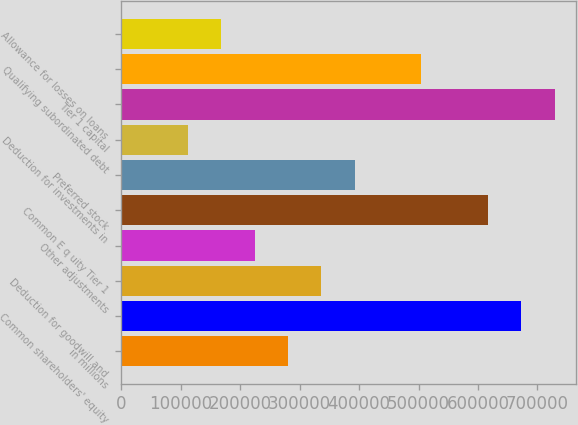<chart> <loc_0><loc_0><loc_500><loc_500><bar_chart><fcel>in millions<fcel>Common shareholders' equity<fcel>Deduction for goodwill and<fcel>Other adjustments<fcel>Common E q uity Tier 1<fcel>Preferred stock<fcel>Deduction for investments in<fcel>Tier 1 capital<fcel>Qualifying subordinated debt<fcel>Allowance for losses on loans<nl><fcel>280399<fcel>672941<fcel>336477<fcel>224322<fcel>616863<fcel>392554<fcel>112167<fcel>729018<fcel>504709<fcel>168245<nl></chart> 